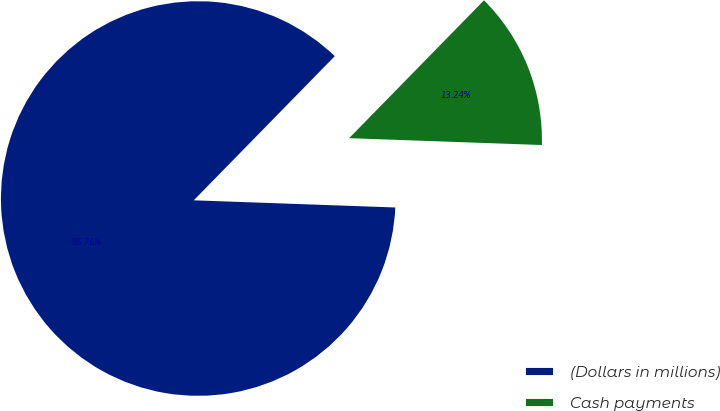Convert chart to OTSL. <chart><loc_0><loc_0><loc_500><loc_500><pie_chart><fcel>(Dollars in millions)<fcel>Cash payments<nl><fcel>86.76%<fcel>13.24%<nl></chart> 